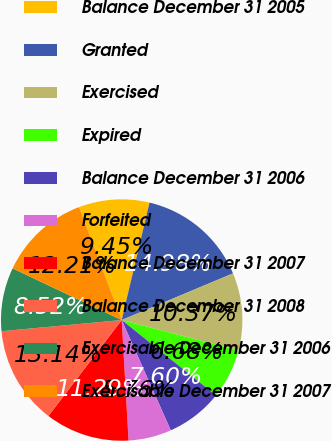Convert chart. <chart><loc_0><loc_0><loc_500><loc_500><pie_chart><fcel>Balance December 31 2005<fcel>Granted<fcel>Exercised<fcel>Expired<fcel>Balance December 31 2006<fcel>Forfeited<fcel>Balance December 31 2007<fcel>Balance December 31 2008<fcel>Exercisable December 31 2006<fcel>Exercisable December 31 2007<nl><fcel>9.45%<fcel>14.98%<fcel>10.37%<fcel>6.68%<fcel>7.6%<fcel>5.76%<fcel>11.29%<fcel>13.14%<fcel>8.52%<fcel>12.21%<nl></chart> 